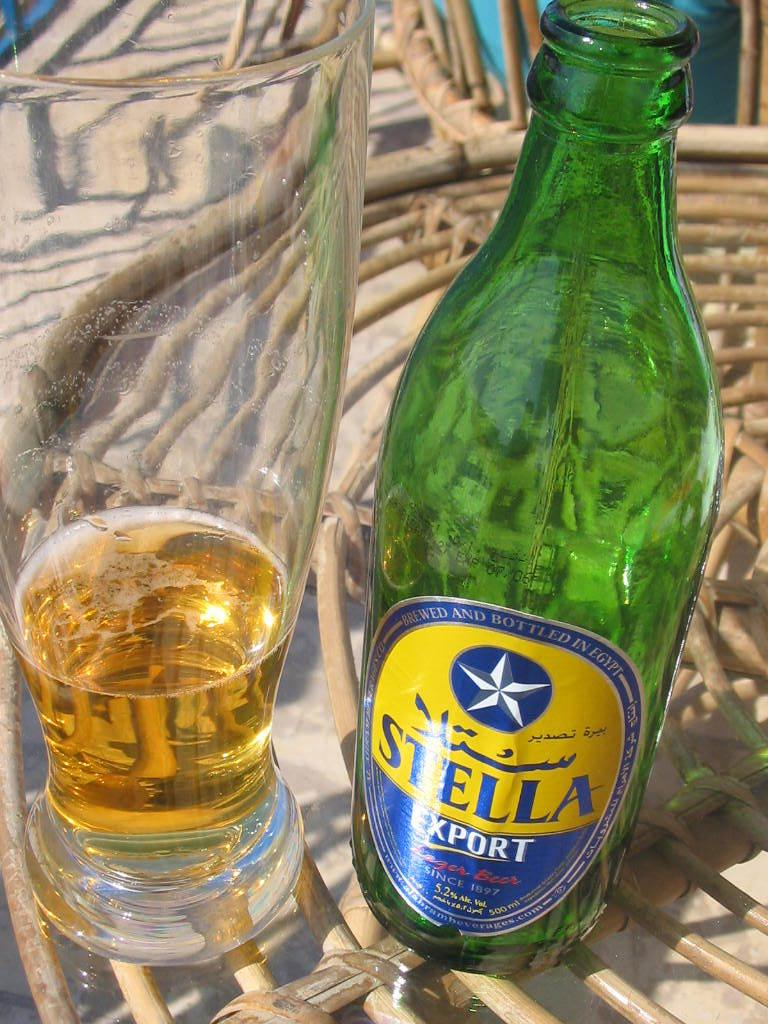<image>
Offer a succinct explanation of the picture presented. A near empty glass of Stella Export lager beer next to the empty bottle. 